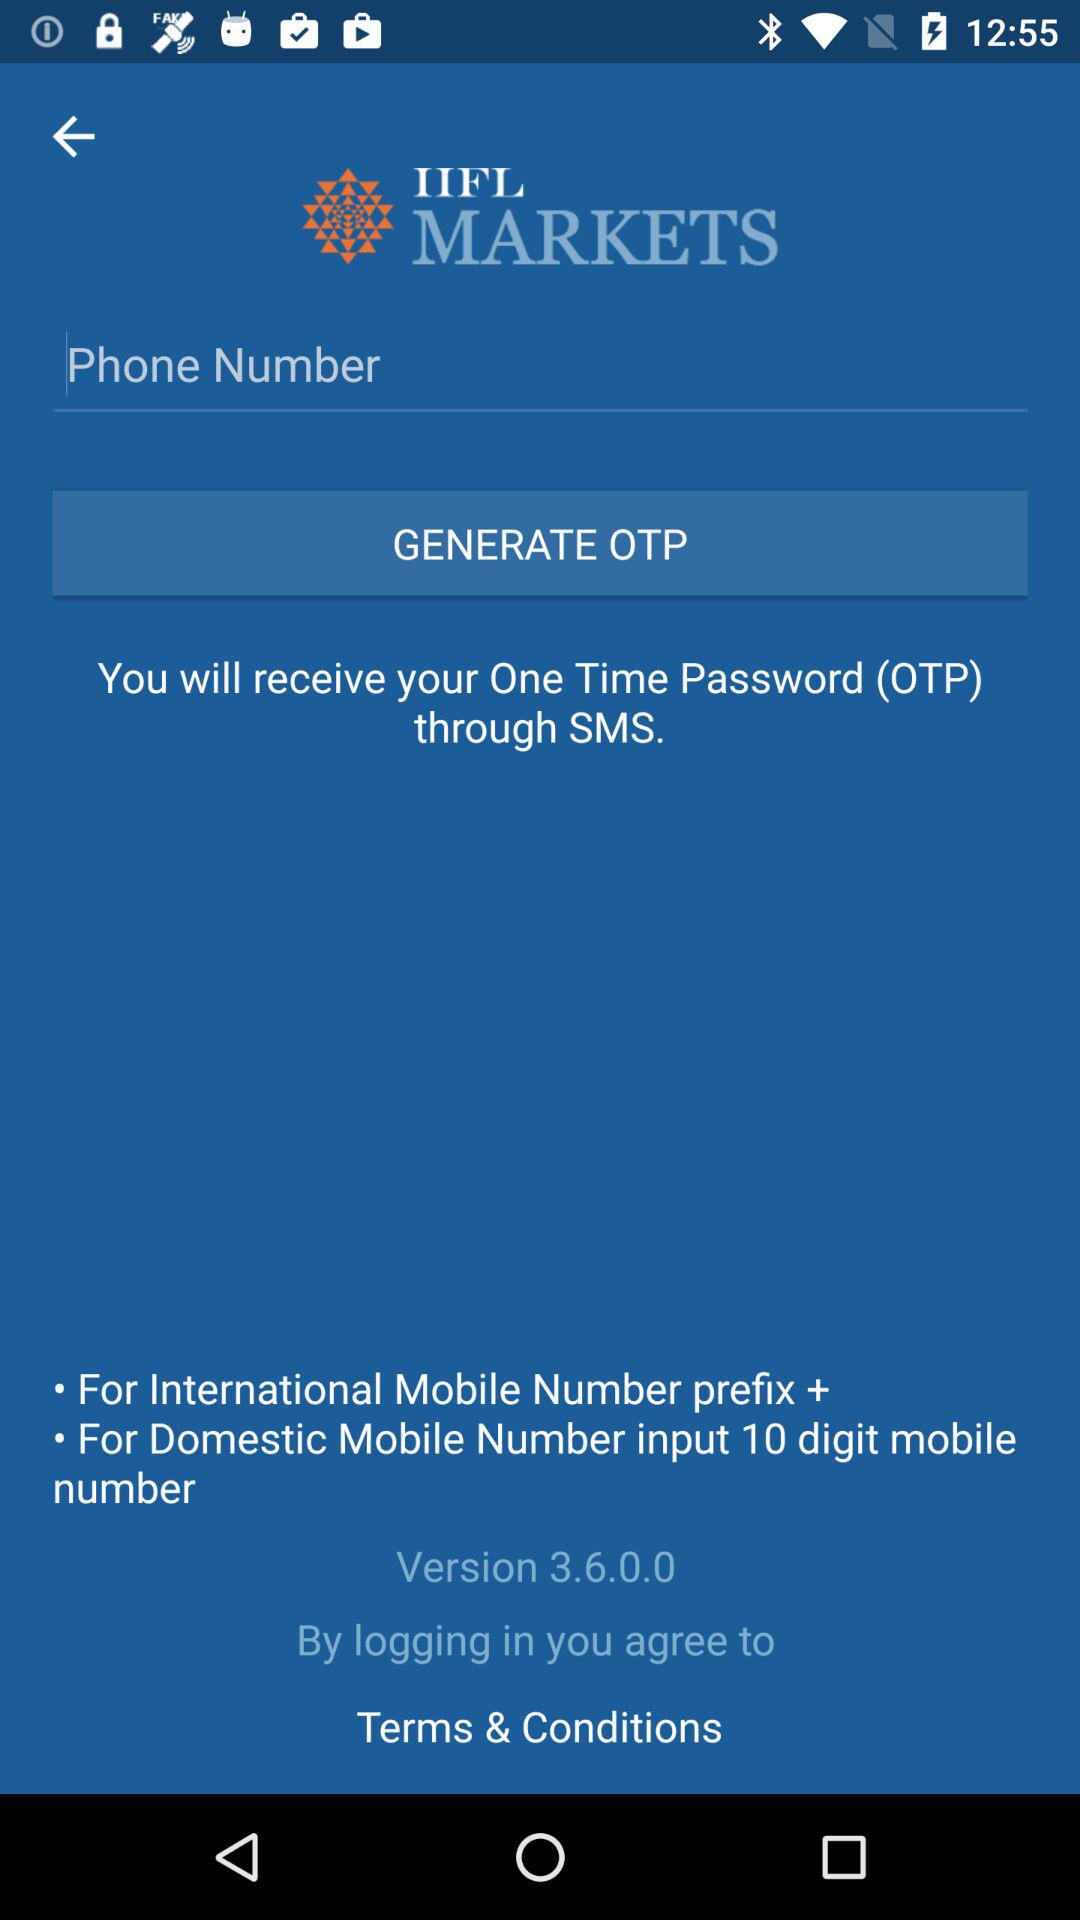What is the name of the application? The name of the application is "IIFL MARKETS". 